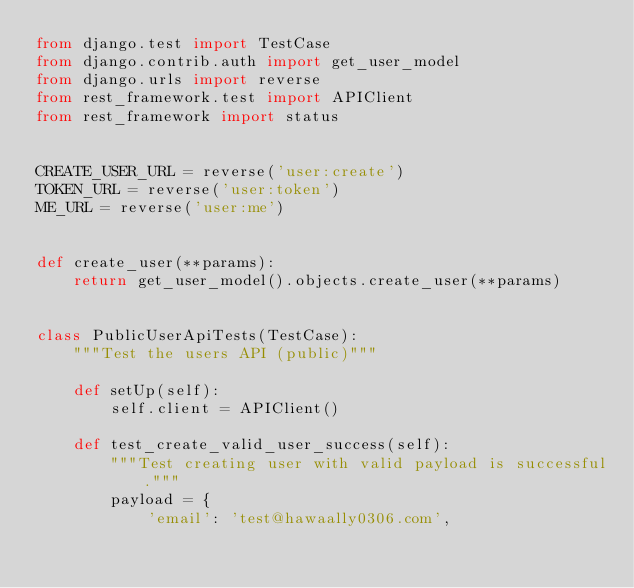<code> <loc_0><loc_0><loc_500><loc_500><_Python_>from django.test import TestCase
from django.contrib.auth import get_user_model
from django.urls import reverse
from rest_framework.test import APIClient
from rest_framework import status


CREATE_USER_URL = reverse('user:create')
TOKEN_URL = reverse('user:token')
ME_URL = reverse('user:me')


def create_user(**params):
    return get_user_model().objects.create_user(**params)


class PublicUserApiTests(TestCase):
    """Test the users API (public)"""

    def setUp(self):
        self.client = APIClient()

    def test_create_valid_user_success(self):
        """Test creating user with valid payload is successful."""
        payload = {
            'email': 'test@hawaally0306.com',</code> 